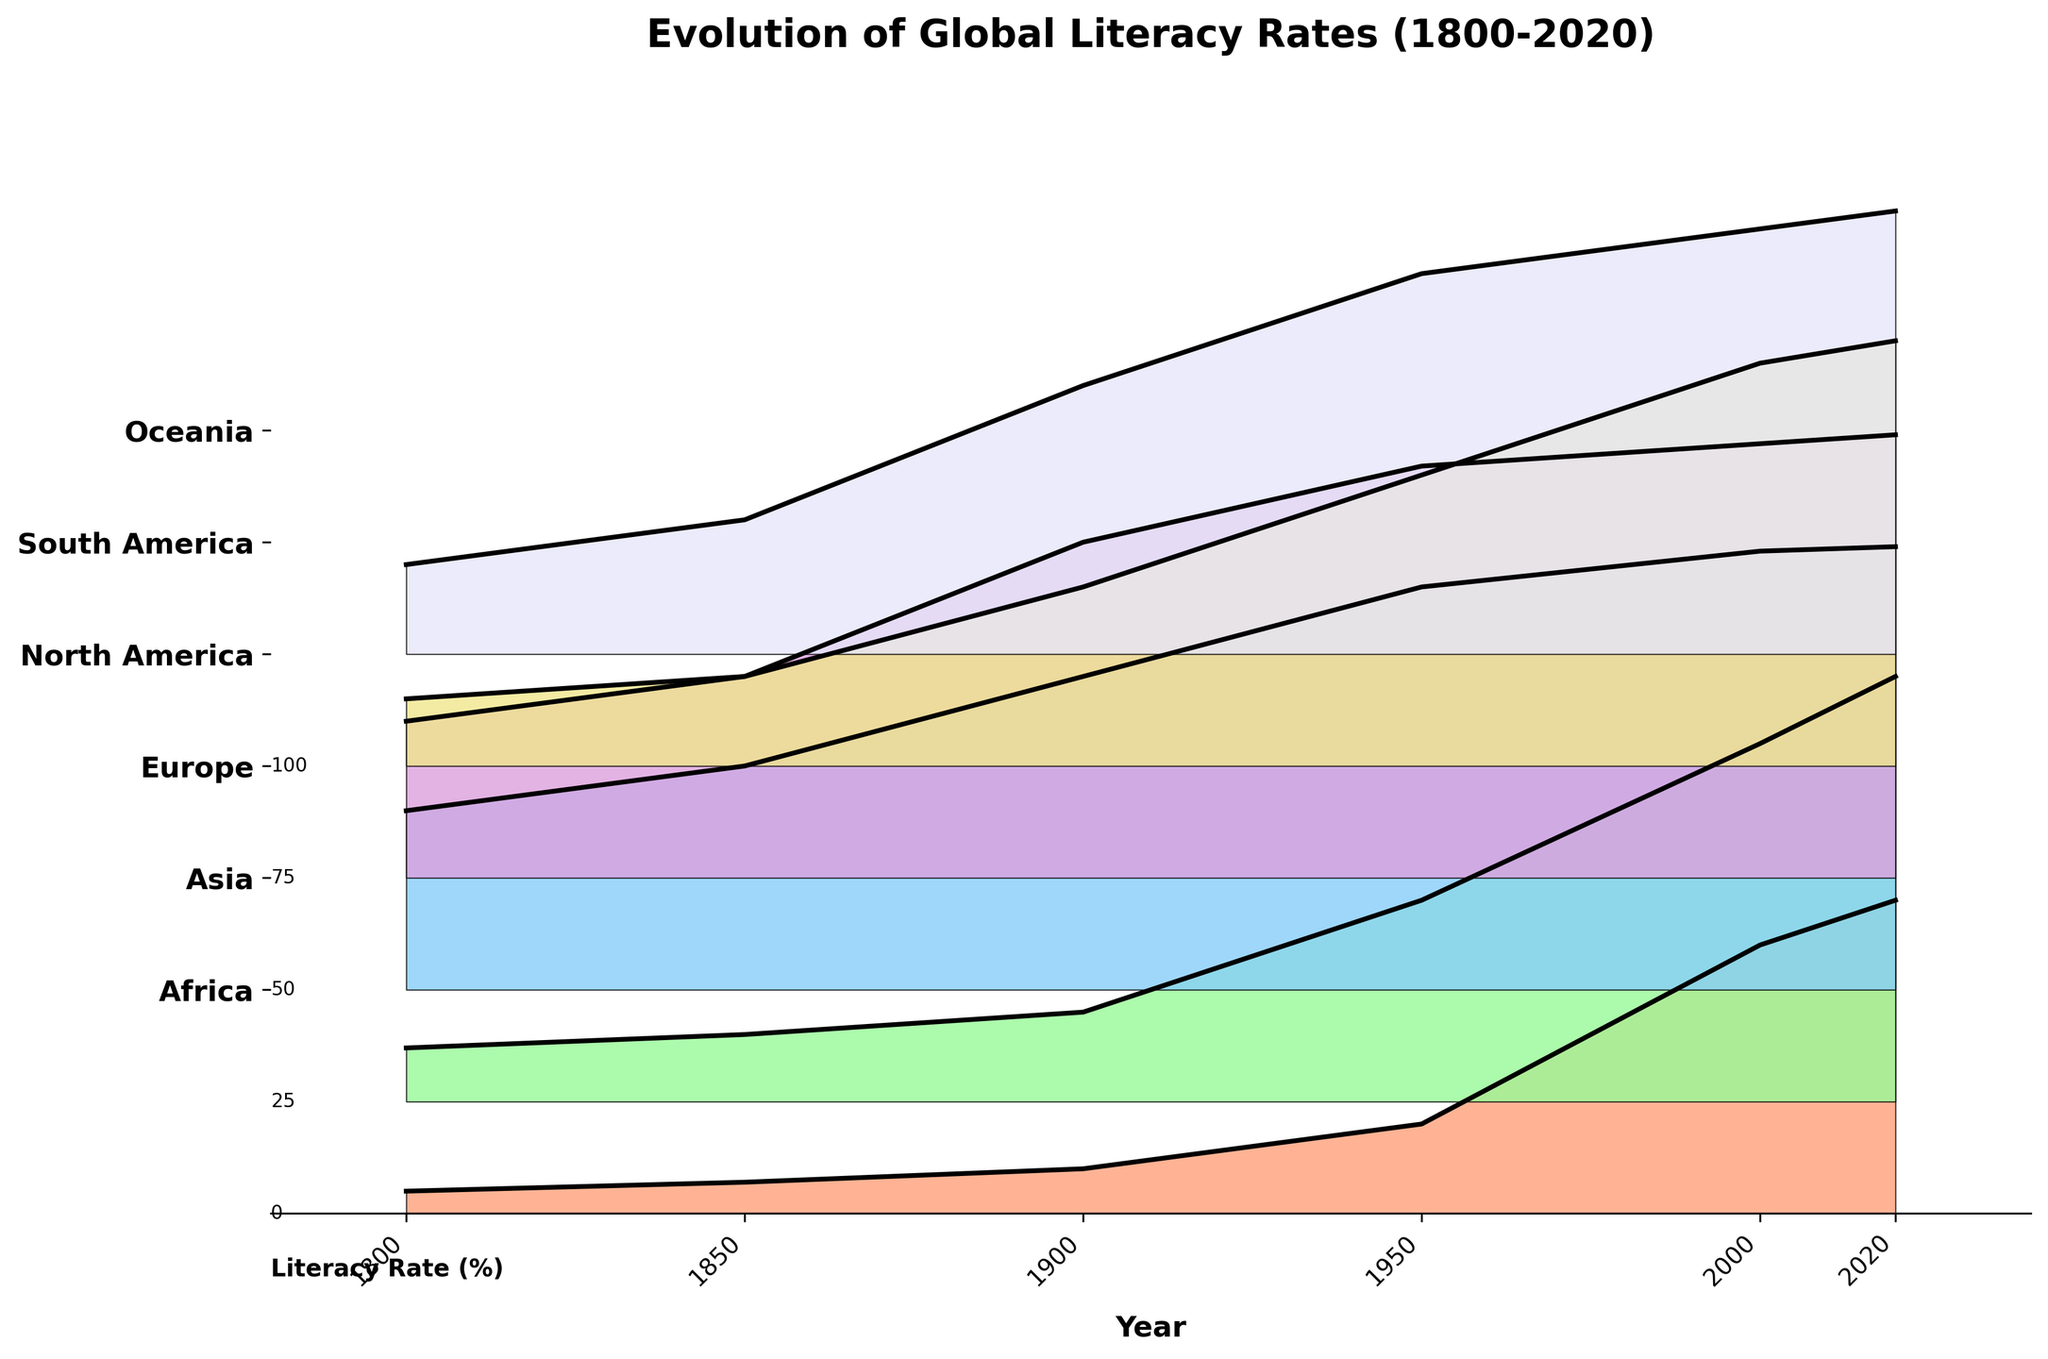What is the time range displayed in the plot? The x-axis of the plot shows years starting from 1800 to 2020, indicating the span of time covered in the figure.
Answer: 1800 to 2020 Which continent has the highest literacy rate in 2020? Looking at the data along the top edge of the ridgeline plot near the year 2020, Europe, North America, and Oceania all reach close to 99%, but the plot shows slight prominence, indicating Europe is slightly ahead.
Answer: Europe How has literacy in Africa changed from 1800 to 2020? Africa starts at about 5% in 1800 and exhibits a gradual increase over time, reaching around 70% by 2020. This is evident by the coloring and height increase in the "Africa" section of the ridgeline plot.
Answer: From 5% to 70% Compare the literacy rate of Asia between 1850 and 1900. The difference in height for Asia between 1850 (15%) and 1900 (20%) indicates a rise in the literacy rate.
Answer: Increased by 5% Which continent showed the greatest improvement in literacy rates between 1800 and 2020? By examining the plot, Europe, which started at around 40% in 1800 and nearly reached 99% by 2020, shows a significant increase overall.
Answer: Europe Is there any continent that reached a literacy rate of 100% by 2020? By checking the heights of the plots by 2020, no continent reaches exactly 100%, but Europe, North America, and Oceania are very close to 99%.
Answer: No Identify a period when literacy rates in South America saw a notable increase. From 1950 to 2000, the line for South America steeply increases from about 65% to 90%. This indicates a significant improvement.
Answer: 1950 to 2000 What can be said about North America's literacy rates from 1950 to 2000? The plot shows a sharp increase in the literacy rate for North America from 92% in 1950 to about 97% in 2000.
Answer: Increased significantly How did literacy rates in Oceania progress over the gathered timeline? Oceania starts at about 20% in 1800, increasing gradually over the years to about 99% in 2020, indicating continuous improvement.
Answer: Increased from 20% to 99% Which continents were ahead in literacy rates around 1900? In 1900, Europe leads with about 70%, followed by North America with 75%, and Oceania with 60%, indicating these continents had higher literacy rates than others.
Answer: Europe and North America 